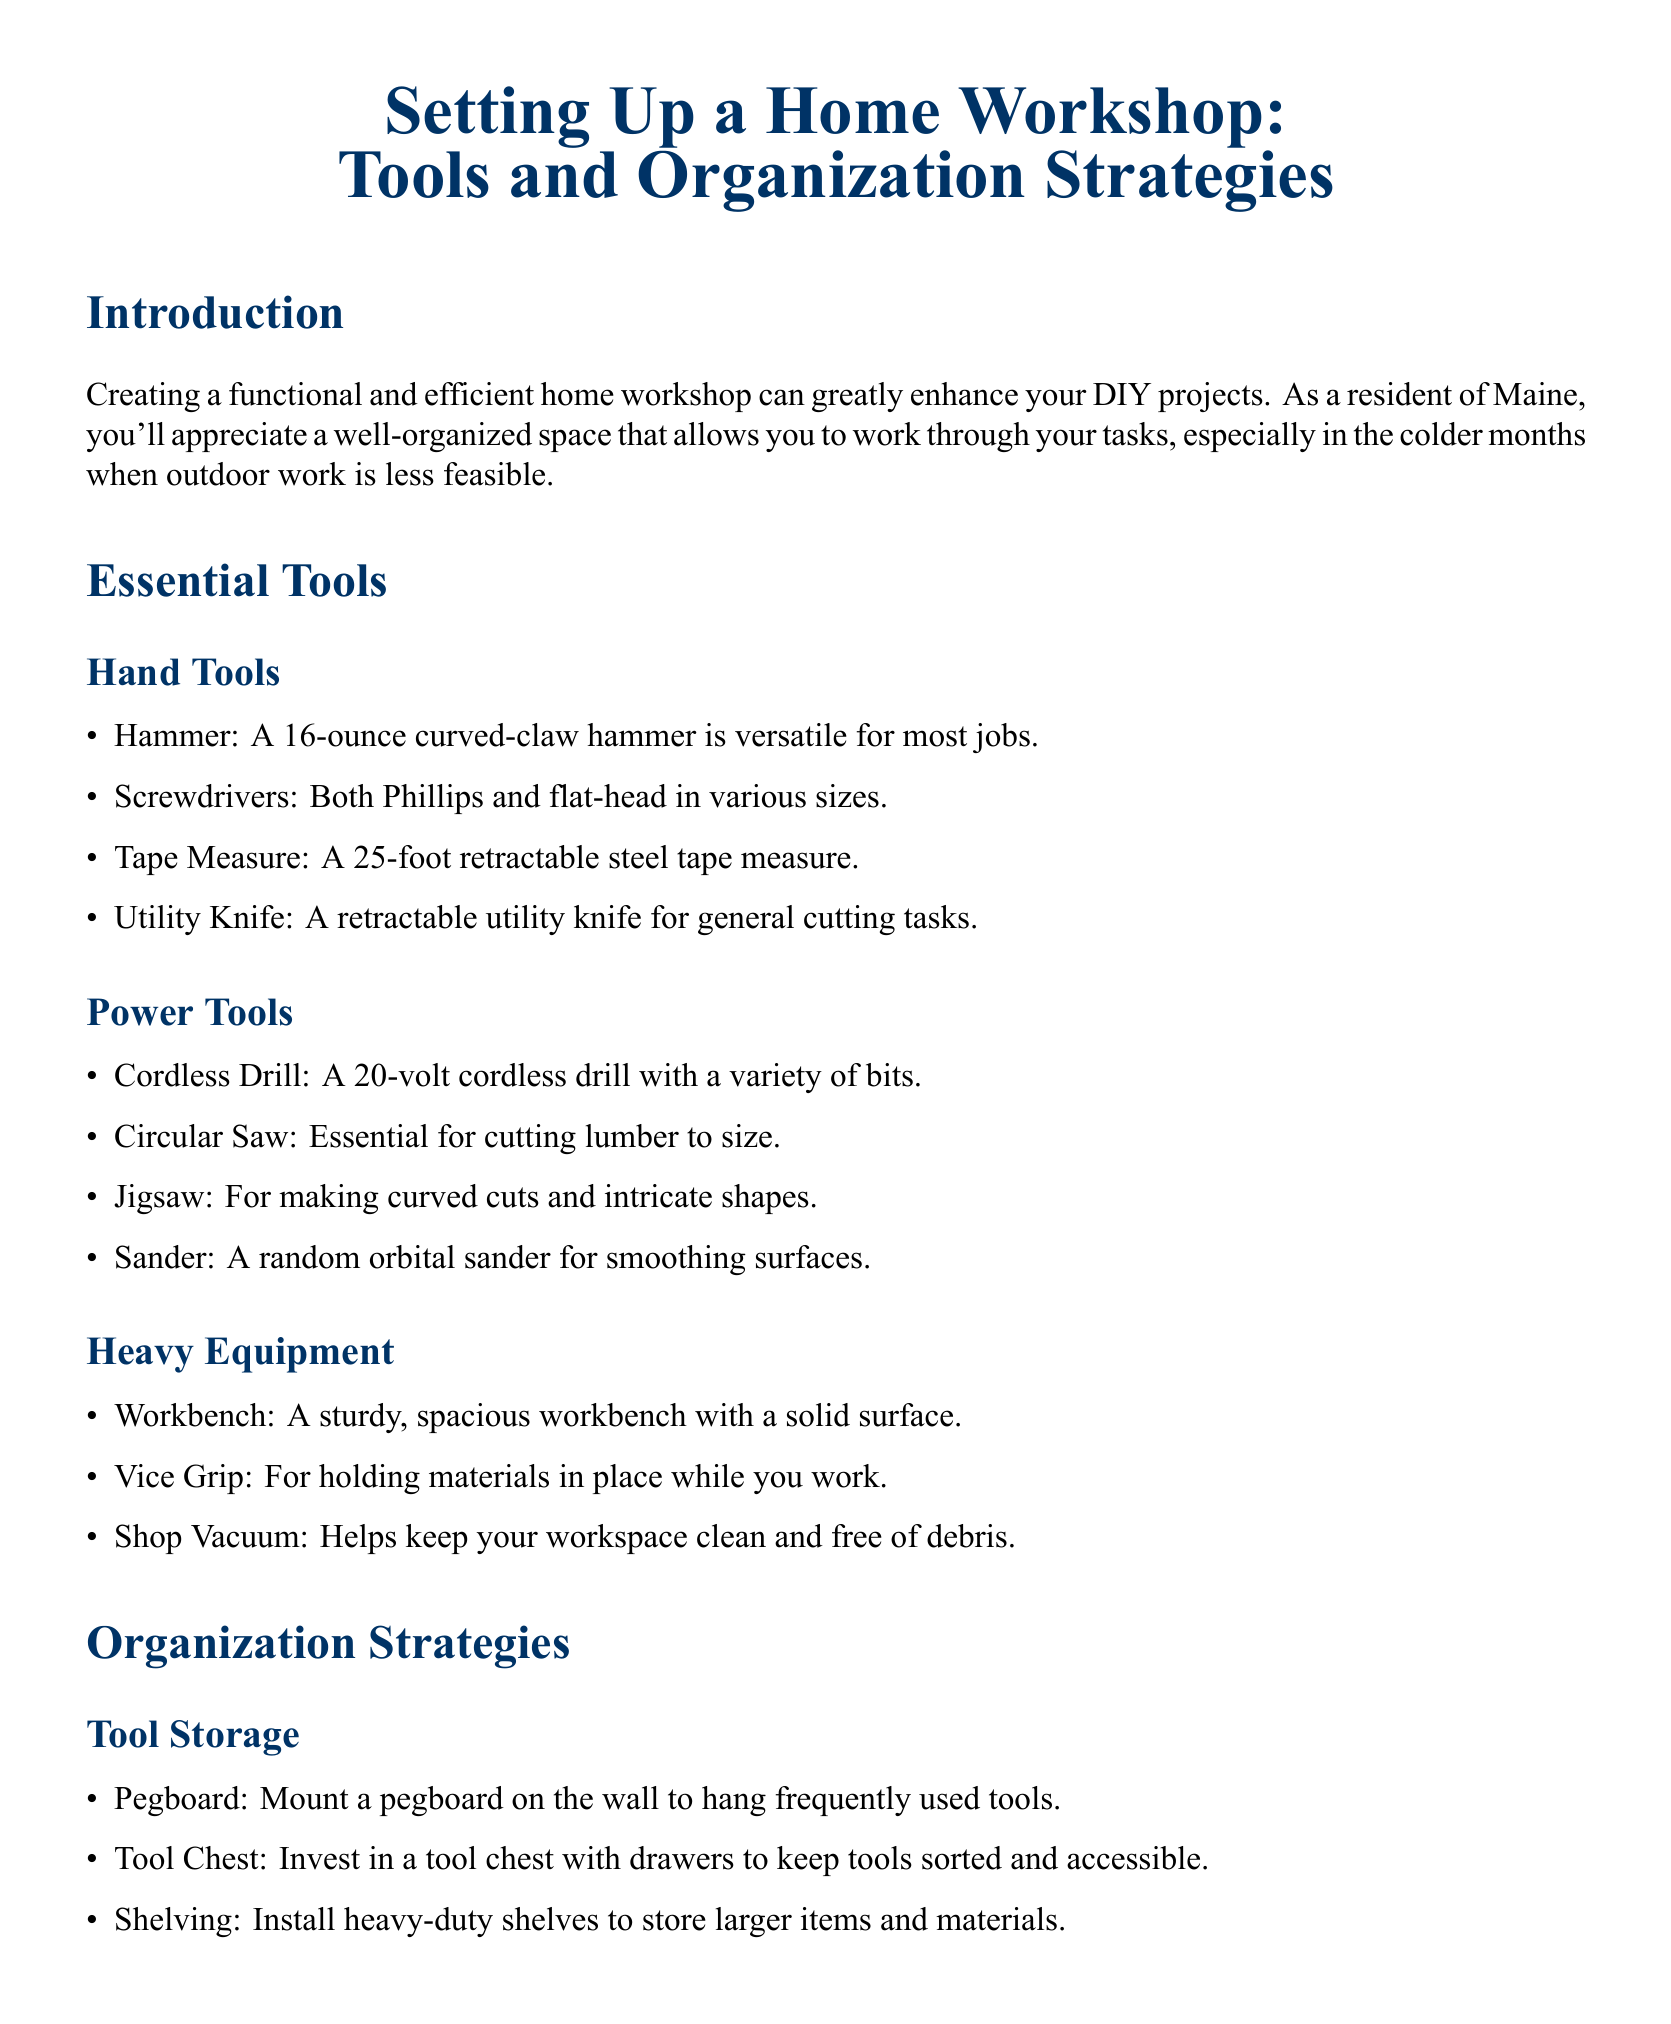What is the title of the document? The title presents the main subject of the document, which is about setting up a home workshop.
Answer: Setting Up a Home Workshop: Tools and Organization Strategies How many types of hand tools are listed? The document lists four types of hand tools under the Essential Tools section.
Answer: Four What is the recommended weight of the hammer? The document specifies the weight of the recommended hammer for general use.
Answer: 16-ounce Which tool is essential for cutting lumber? The document indicates a specific power tool required for cutting lumber effectively.
Answer: Circular Saw What strategy is suggested for tool storage? The document includes a strategy for organizing tools in a home workshop.
Answer: Pegboard What type of storage bin is recommended for small parts? The document describes the suitability of a particular type of storage for organizing small items.
Answer: Clear plastic storage bins How many safety considerations are mentioned? The document outlines three important safety considerations relevant to workshop safety.
Answer: Three What is one piece of heavy equipment listed? A specific item categorized as heavy equipment is included in the Essential Tools section of the document.
Answer: Workbench What should be kept easily accessible according to the safety considerations? The document states an item that should be within quick reach in case of emergencies.
Answer: Fire Extinguisher 